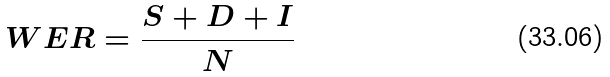Convert formula to latex. <formula><loc_0><loc_0><loc_500><loc_500>W E R = \frac { S + D + I } { N }</formula> 